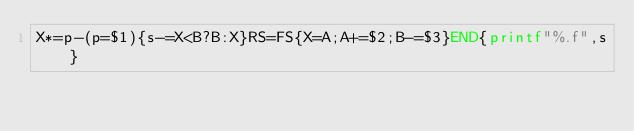<code> <loc_0><loc_0><loc_500><loc_500><_Awk_>X*=p-(p=$1){s-=X<B?B:X}RS=FS{X=A;A+=$2;B-=$3}END{printf"%.f",s}</code> 